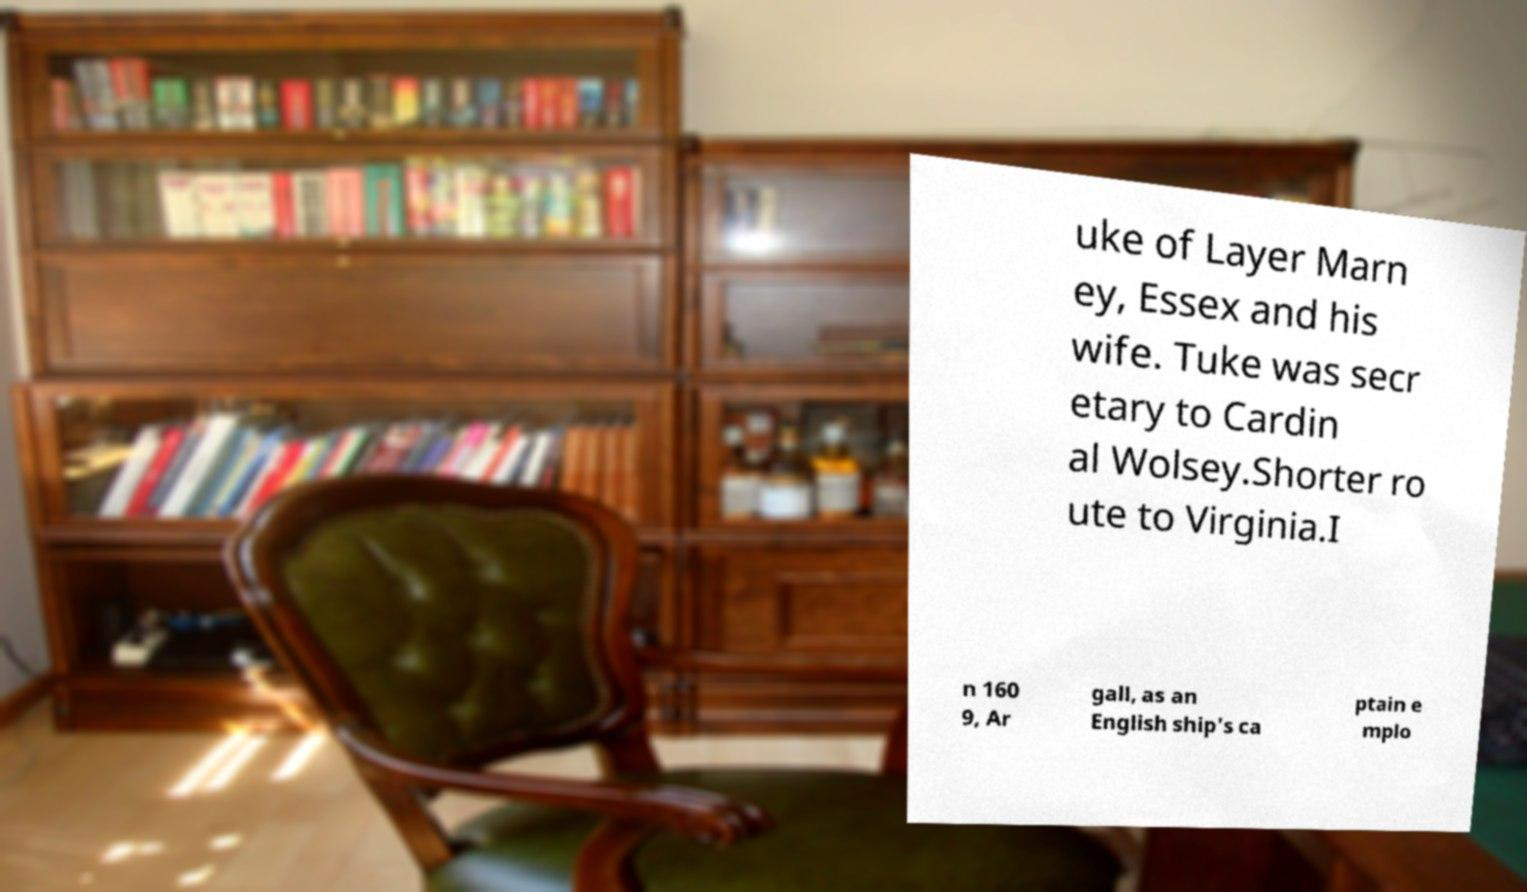Can you read and provide the text displayed in the image?This photo seems to have some interesting text. Can you extract and type it out for me? uke of Layer Marn ey, Essex and his wife. Tuke was secr etary to Cardin al Wolsey.Shorter ro ute to Virginia.I n 160 9, Ar gall, as an English ship's ca ptain e mplo 